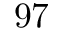<formula> <loc_0><loc_0><loc_500><loc_500>9 7</formula> 